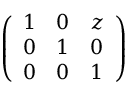<formula> <loc_0><loc_0><loc_500><loc_500>\left ( \begin{array} { l l l } { 1 } & { 0 } & { z } \\ { 0 } & { 1 } & { 0 } \\ { 0 } & { 0 } & { 1 } \end{array} \right )</formula> 